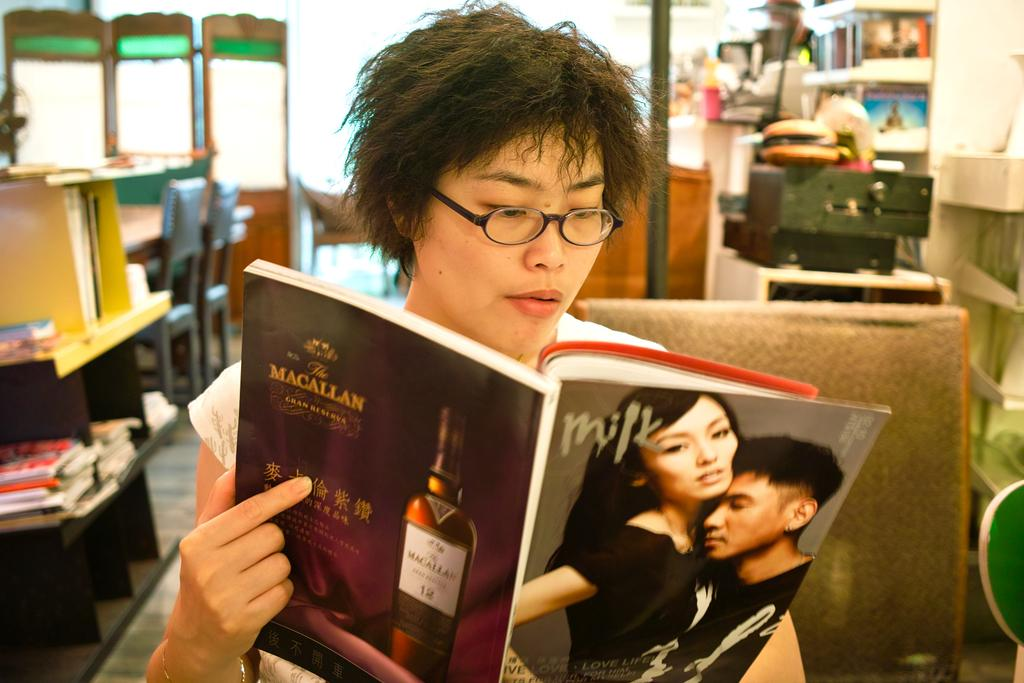What is the person in the image doing? The person is looking at a book. What can be seen on the person's face? The person is wearing spectacles. What is visible on the floor in the image? There are books on the floor. Can you describe the background of the image? There is a table, chairs, a pole, and racks in the background. What type of pancake is being served on the table in the image? There is no pancake present in the image; the table is not the focus of the image. --- Facts: 1. There is a person in the image. 2. The person is holding a cup. 3. The cup has a handle. 4. The person is wearing a hat. 5. The image shows a wall. 6. There is a door in the wall. 7. There is a window in the wall. 8. There is a plant on the window sill. Absurd Topics: parrot, bicycle, ocean Conversation: What is the person in the image holding? The person is holding a cup. What can be seen on the cup? The cup has a handle. What is the person wearing on their head? The person is wearing a hat. Can you describe the wall in the image? There is a door and a window in the wall. What is on the window sill? There is a plant on the window sill. Reasoning: Let's think step by step in order to produce the conversation. We start by identifying the main subject in the image, which is the person. Then, we describe what the person is holding and what they are wearing. Next, we expand the conversation to include other items that are also visible, such as the wall, door, window, and plant. Each question is designed to elicit a specific detail about the image that is known from the provided facts. Absurd Question/Answer: Can you see a parrot sitting on the bicycle near the ocean in the image? There is no parrot, bicycle, or ocean present in the image. 